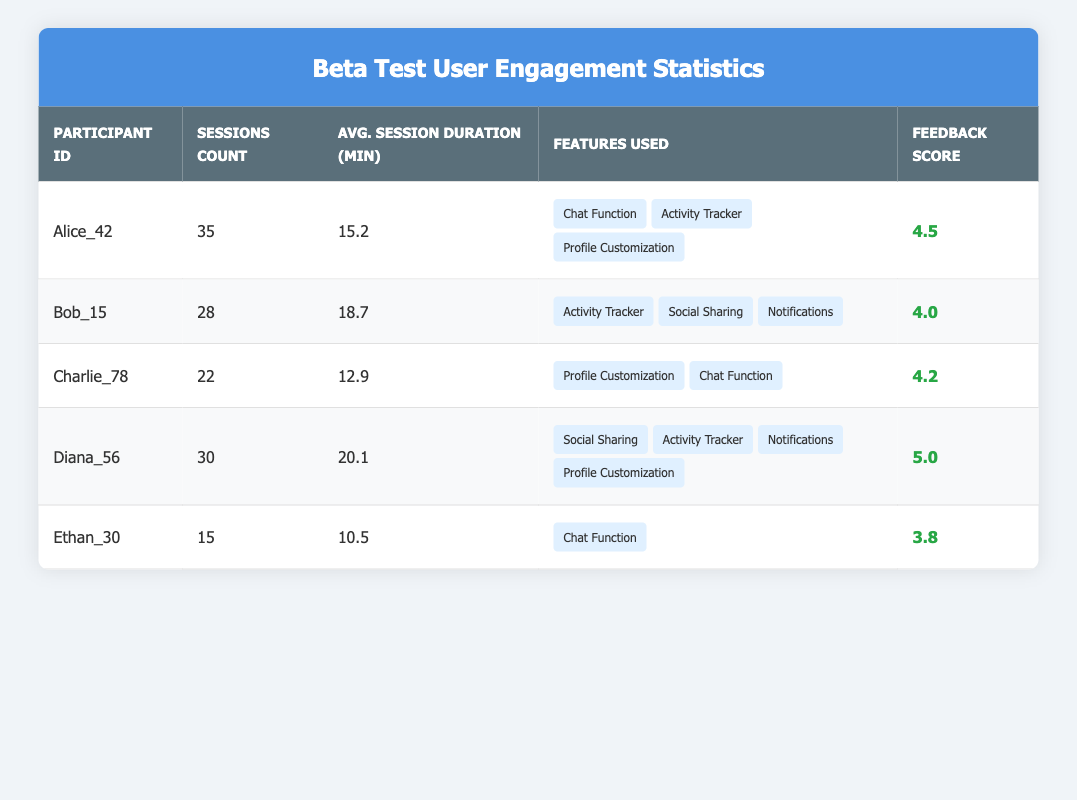What is the participant ID of the user with the highest feedback score? The highest feedback score in the table is 5.0, which corresponds to the participant ID Diana_56.
Answer: Diana_56 How many sessions did Alice complete during the beta test? Alice's sessions count is directly listed in the table as 35.
Answer: 35 What is the average session duration for Bob? The average session duration for Bob is listed in the table as 18.7 minutes.
Answer: 18.7 Which participant used the fewest features? The table shows that Ethan_30 only used one feature, the Chat Function, which is fewer than any other participant.
Answer: Ethan_30 What is the total number of sessions completed by all participants? Summing the sessions count: 35 (Alice) + 28 (Bob) + 22 (Charlie) + 30 (Diana) + 15 (Ethan) equals 130 sessions in total.
Answer: 130 Is there a user who has a feedback score of 4 or higher but has less than 20 sessions? Looking at the table, Charlie has a feedback score of 4.2 with 22 sessions, and Ethan has a score of 3.8 with 15 sessions, confirming no user meets the criteria.
Answer: No What is the median average session duration among the participants? First, list the average session durations: 15.2, 18.7, 12.9, 20.1, 10.5. When ordered (10.5, 12.9, 15.2, 18.7, 20.1), the median is the third value, which is 15.2 minutes.
Answer: 15.2 Which features are common between Alice and Charlie? Alice uses Chat Function, Activity Tracker, and Profile Customization; Charlie uses Profile Customization and Chat Function, making the common features Chat Function and Profile Customization.
Answer: Chat Function, Profile Customization How many total features were used across all participants? Combining the features used by each participant: Alice (3) + Bob (3) + Charlie (2) + Diana (4) + Ethan (1) results in a total of 13 features used across all.
Answer: 13 